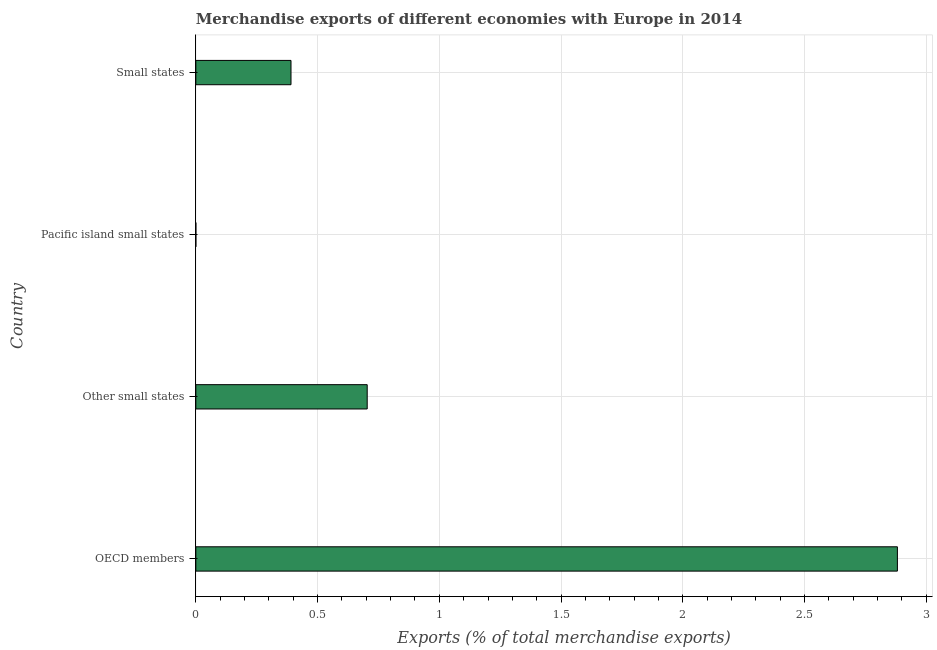Does the graph contain any zero values?
Ensure brevity in your answer.  No. Does the graph contain grids?
Ensure brevity in your answer.  Yes. What is the title of the graph?
Make the answer very short. Merchandise exports of different economies with Europe in 2014. What is the label or title of the X-axis?
Give a very brief answer. Exports (% of total merchandise exports). What is the merchandise exports in OECD members?
Your answer should be very brief. 2.88. Across all countries, what is the maximum merchandise exports?
Your answer should be very brief. 2.88. Across all countries, what is the minimum merchandise exports?
Offer a terse response. 4.41288533576505e-5. In which country was the merchandise exports maximum?
Keep it short and to the point. OECD members. In which country was the merchandise exports minimum?
Ensure brevity in your answer.  Pacific island small states. What is the sum of the merchandise exports?
Your answer should be compact. 3.98. What is the difference between the merchandise exports in Other small states and Small states?
Keep it short and to the point. 0.31. What is the average merchandise exports per country?
Provide a short and direct response. 0.99. What is the median merchandise exports?
Offer a terse response. 0.55. What is the ratio of the merchandise exports in OECD members to that in Small states?
Give a very brief answer. 7.37. Is the difference between the merchandise exports in OECD members and Other small states greater than the difference between any two countries?
Offer a terse response. No. What is the difference between the highest and the second highest merchandise exports?
Give a very brief answer. 2.18. What is the difference between the highest and the lowest merchandise exports?
Make the answer very short. 2.88. In how many countries, is the merchandise exports greater than the average merchandise exports taken over all countries?
Ensure brevity in your answer.  1. How many bars are there?
Make the answer very short. 4. Are all the bars in the graph horizontal?
Provide a short and direct response. Yes. What is the Exports (% of total merchandise exports) of OECD members?
Give a very brief answer. 2.88. What is the Exports (% of total merchandise exports) of Other small states?
Provide a short and direct response. 0.7. What is the Exports (% of total merchandise exports) in Pacific island small states?
Provide a succinct answer. 4.41288533576505e-5. What is the Exports (% of total merchandise exports) in Small states?
Offer a very short reply. 0.39. What is the difference between the Exports (% of total merchandise exports) in OECD members and Other small states?
Make the answer very short. 2.18. What is the difference between the Exports (% of total merchandise exports) in OECD members and Pacific island small states?
Provide a succinct answer. 2.88. What is the difference between the Exports (% of total merchandise exports) in OECD members and Small states?
Your answer should be very brief. 2.49. What is the difference between the Exports (% of total merchandise exports) in Other small states and Pacific island small states?
Provide a short and direct response. 0.7. What is the difference between the Exports (% of total merchandise exports) in Other small states and Small states?
Offer a very short reply. 0.31. What is the difference between the Exports (% of total merchandise exports) in Pacific island small states and Small states?
Ensure brevity in your answer.  -0.39. What is the ratio of the Exports (% of total merchandise exports) in OECD members to that in Other small states?
Offer a very short reply. 4.09. What is the ratio of the Exports (% of total merchandise exports) in OECD members to that in Pacific island small states?
Ensure brevity in your answer.  6.53e+04. What is the ratio of the Exports (% of total merchandise exports) in OECD members to that in Small states?
Ensure brevity in your answer.  7.37. What is the ratio of the Exports (% of total merchandise exports) in Other small states to that in Pacific island small states?
Offer a very short reply. 1.60e+04. What is the ratio of the Exports (% of total merchandise exports) in Other small states to that in Small states?
Keep it short and to the point. 1.8. 